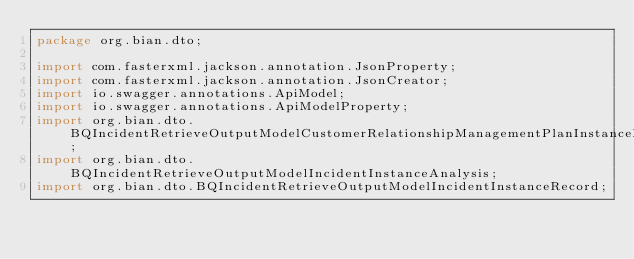Convert code to text. <code><loc_0><loc_0><loc_500><loc_500><_Java_>package org.bian.dto;

import com.fasterxml.jackson.annotation.JsonProperty;
import com.fasterxml.jackson.annotation.JsonCreator;
import io.swagger.annotations.ApiModel;
import io.swagger.annotations.ApiModelProperty;
import org.bian.dto.BQIncidentRetrieveOutputModelCustomerRelationshipManagementPlanInstanceRecord;
import org.bian.dto.BQIncidentRetrieveOutputModelIncidentInstanceAnalysis;
import org.bian.dto.BQIncidentRetrieveOutputModelIncidentInstanceRecord;</code> 